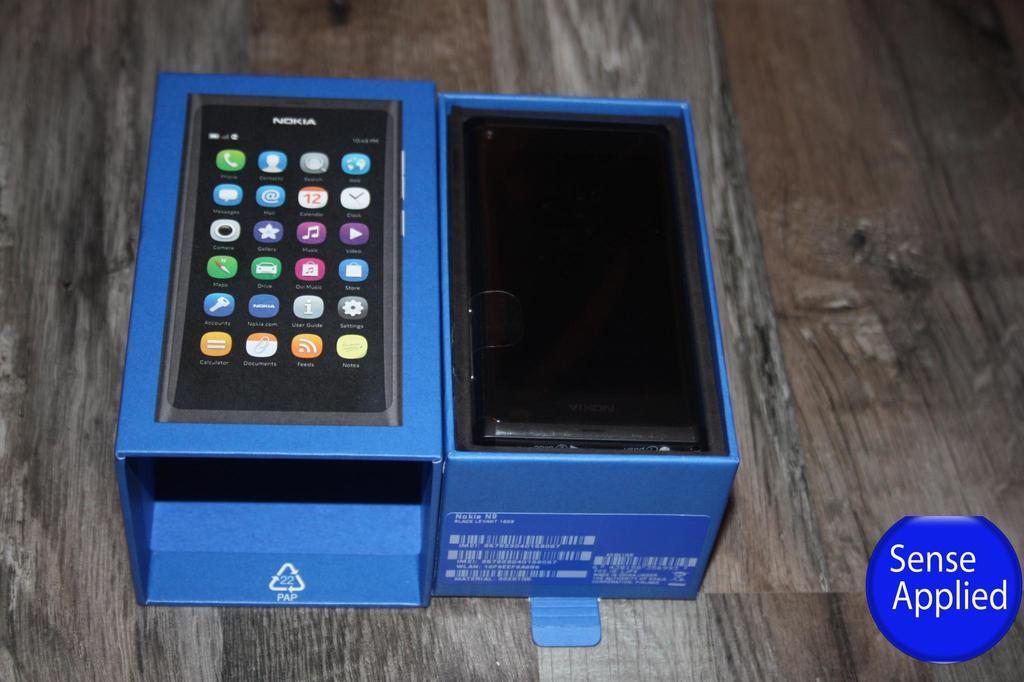What is applied?
Ensure brevity in your answer.  Sense. What brand is this?
Offer a terse response. Nokia. 